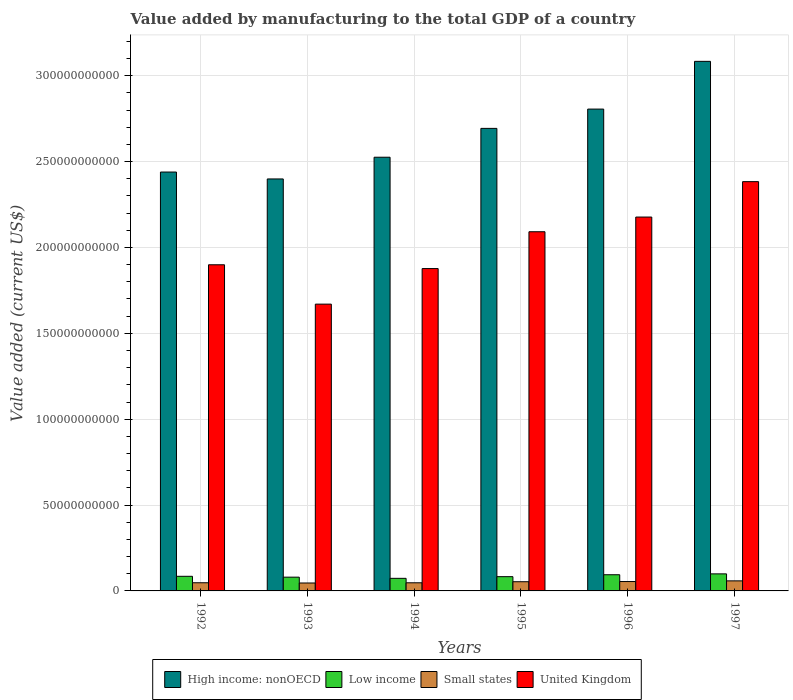How many groups of bars are there?
Provide a succinct answer. 6. Are the number of bars per tick equal to the number of legend labels?
Provide a short and direct response. Yes. Are the number of bars on each tick of the X-axis equal?
Provide a short and direct response. Yes. What is the value added by manufacturing to the total GDP in Low income in 1996?
Keep it short and to the point. 9.42e+09. Across all years, what is the maximum value added by manufacturing to the total GDP in Low income?
Give a very brief answer. 9.93e+09. Across all years, what is the minimum value added by manufacturing to the total GDP in High income: nonOECD?
Ensure brevity in your answer.  2.40e+11. What is the total value added by manufacturing to the total GDP in United Kingdom in the graph?
Ensure brevity in your answer.  1.21e+12. What is the difference between the value added by manufacturing to the total GDP in High income: nonOECD in 1994 and that in 1996?
Your answer should be compact. -2.80e+1. What is the difference between the value added by manufacturing to the total GDP in Small states in 1996 and the value added by manufacturing to the total GDP in High income: nonOECD in 1995?
Offer a terse response. -2.64e+11. What is the average value added by manufacturing to the total GDP in High income: nonOECD per year?
Keep it short and to the point. 2.66e+11. In the year 1995, what is the difference between the value added by manufacturing to the total GDP in Low income and value added by manufacturing to the total GDP in Small states?
Make the answer very short. 2.94e+09. What is the ratio of the value added by manufacturing to the total GDP in United Kingdom in 1993 to that in 1995?
Offer a very short reply. 0.8. What is the difference between the highest and the second highest value added by manufacturing to the total GDP in High income: nonOECD?
Your answer should be very brief. 2.78e+1. What is the difference between the highest and the lowest value added by manufacturing to the total GDP in High income: nonOECD?
Make the answer very short. 6.85e+1. Is it the case that in every year, the sum of the value added by manufacturing to the total GDP in High income: nonOECD and value added by manufacturing to the total GDP in Low income is greater than the sum of value added by manufacturing to the total GDP in United Kingdom and value added by manufacturing to the total GDP in Small states?
Ensure brevity in your answer.  Yes. What does the 2nd bar from the right in 1997 represents?
Your answer should be compact. Small states. Is it the case that in every year, the sum of the value added by manufacturing to the total GDP in Low income and value added by manufacturing to the total GDP in Small states is greater than the value added by manufacturing to the total GDP in United Kingdom?
Give a very brief answer. No. How many bars are there?
Your response must be concise. 24. Are all the bars in the graph horizontal?
Provide a short and direct response. No. How many years are there in the graph?
Offer a very short reply. 6. Does the graph contain any zero values?
Provide a succinct answer. No. Does the graph contain grids?
Your response must be concise. Yes. Where does the legend appear in the graph?
Offer a terse response. Bottom center. What is the title of the graph?
Offer a terse response. Value added by manufacturing to the total GDP of a country. What is the label or title of the Y-axis?
Keep it short and to the point. Value added (current US$). What is the Value added (current US$) of High income: nonOECD in 1992?
Provide a succinct answer. 2.44e+11. What is the Value added (current US$) in Low income in 1992?
Offer a very short reply. 8.51e+09. What is the Value added (current US$) in Small states in 1992?
Your answer should be very brief. 4.76e+09. What is the Value added (current US$) of United Kingdom in 1992?
Your answer should be compact. 1.90e+11. What is the Value added (current US$) in High income: nonOECD in 1993?
Provide a short and direct response. 2.40e+11. What is the Value added (current US$) in Low income in 1993?
Your answer should be compact. 8.01e+09. What is the Value added (current US$) of Small states in 1993?
Provide a short and direct response. 4.62e+09. What is the Value added (current US$) of United Kingdom in 1993?
Ensure brevity in your answer.  1.67e+11. What is the Value added (current US$) in High income: nonOECD in 1994?
Offer a terse response. 2.53e+11. What is the Value added (current US$) of Low income in 1994?
Provide a succinct answer. 7.33e+09. What is the Value added (current US$) of Small states in 1994?
Offer a very short reply. 4.74e+09. What is the Value added (current US$) in United Kingdom in 1994?
Offer a terse response. 1.88e+11. What is the Value added (current US$) of High income: nonOECD in 1995?
Your answer should be compact. 2.69e+11. What is the Value added (current US$) in Low income in 1995?
Offer a very short reply. 8.30e+09. What is the Value added (current US$) in Small states in 1995?
Make the answer very short. 5.35e+09. What is the Value added (current US$) in United Kingdom in 1995?
Make the answer very short. 2.09e+11. What is the Value added (current US$) of High income: nonOECD in 1996?
Give a very brief answer. 2.81e+11. What is the Value added (current US$) in Low income in 1996?
Provide a succinct answer. 9.42e+09. What is the Value added (current US$) of Small states in 1996?
Your answer should be very brief. 5.46e+09. What is the Value added (current US$) in United Kingdom in 1996?
Provide a short and direct response. 2.18e+11. What is the Value added (current US$) of High income: nonOECD in 1997?
Give a very brief answer. 3.08e+11. What is the Value added (current US$) in Low income in 1997?
Offer a terse response. 9.93e+09. What is the Value added (current US$) of Small states in 1997?
Your response must be concise. 5.85e+09. What is the Value added (current US$) in United Kingdom in 1997?
Keep it short and to the point. 2.38e+11. Across all years, what is the maximum Value added (current US$) in High income: nonOECD?
Provide a short and direct response. 3.08e+11. Across all years, what is the maximum Value added (current US$) in Low income?
Provide a succinct answer. 9.93e+09. Across all years, what is the maximum Value added (current US$) in Small states?
Your answer should be very brief. 5.85e+09. Across all years, what is the maximum Value added (current US$) of United Kingdom?
Ensure brevity in your answer.  2.38e+11. Across all years, what is the minimum Value added (current US$) in High income: nonOECD?
Offer a terse response. 2.40e+11. Across all years, what is the minimum Value added (current US$) of Low income?
Keep it short and to the point. 7.33e+09. Across all years, what is the minimum Value added (current US$) in Small states?
Provide a short and direct response. 4.62e+09. Across all years, what is the minimum Value added (current US$) of United Kingdom?
Give a very brief answer. 1.67e+11. What is the total Value added (current US$) in High income: nonOECD in the graph?
Your response must be concise. 1.59e+12. What is the total Value added (current US$) of Low income in the graph?
Your answer should be compact. 5.15e+1. What is the total Value added (current US$) of Small states in the graph?
Give a very brief answer. 3.08e+1. What is the total Value added (current US$) in United Kingdom in the graph?
Keep it short and to the point. 1.21e+12. What is the difference between the Value added (current US$) of High income: nonOECD in 1992 and that in 1993?
Make the answer very short. 4.03e+09. What is the difference between the Value added (current US$) in Low income in 1992 and that in 1993?
Make the answer very short. 5.07e+08. What is the difference between the Value added (current US$) of Small states in 1992 and that in 1993?
Offer a very short reply. 1.36e+08. What is the difference between the Value added (current US$) in United Kingdom in 1992 and that in 1993?
Your answer should be compact. 2.29e+1. What is the difference between the Value added (current US$) in High income: nonOECD in 1992 and that in 1994?
Give a very brief answer. -8.62e+09. What is the difference between the Value added (current US$) in Low income in 1992 and that in 1994?
Make the answer very short. 1.18e+09. What is the difference between the Value added (current US$) in Small states in 1992 and that in 1994?
Ensure brevity in your answer.  2.15e+07. What is the difference between the Value added (current US$) of United Kingdom in 1992 and that in 1994?
Give a very brief answer. 2.21e+09. What is the difference between the Value added (current US$) in High income: nonOECD in 1992 and that in 1995?
Your response must be concise. -2.54e+1. What is the difference between the Value added (current US$) in Low income in 1992 and that in 1995?
Keep it short and to the point. 2.16e+08. What is the difference between the Value added (current US$) in Small states in 1992 and that in 1995?
Provide a short and direct response. -5.97e+08. What is the difference between the Value added (current US$) of United Kingdom in 1992 and that in 1995?
Your answer should be very brief. -1.92e+1. What is the difference between the Value added (current US$) in High income: nonOECD in 1992 and that in 1996?
Your answer should be compact. -3.67e+1. What is the difference between the Value added (current US$) in Low income in 1992 and that in 1996?
Your response must be concise. -9.07e+08. What is the difference between the Value added (current US$) of Small states in 1992 and that in 1996?
Provide a short and direct response. -7.06e+08. What is the difference between the Value added (current US$) of United Kingdom in 1992 and that in 1996?
Your response must be concise. -2.78e+1. What is the difference between the Value added (current US$) in High income: nonOECD in 1992 and that in 1997?
Your response must be concise. -6.44e+1. What is the difference between the Value added (current US$) in Low income in 1992 and that in 1997?
Provide a short and direct response. -1.41e+09. What is the difference between the Value added (current US$) in Small states in 1992 and that in 1997?
Offer a very short reply. -1.10e+09. What is the difference between the Value added (current US$) of United Kingdom in 1992 and that in 1997?
Make the answer very short. -4.84e+1. What is the difference between the Value added (current US$) in High income: nonOECD in 1993 and that in 1994?
Your answer should be very brief. -1.26e+1. What is the difference between the Value added (current US$) of Low income in 1993 and that in 1994?
Your answer should be very brief. 6.75e+08. What is the difference between the Value added (current US$) of Small states in 1993 and that in 1994?
Your answer should be compact. -1.15e+08. What is the difference between the Value added (current US$) in United Kingdom in 1993 and that in 1994?
Your answer should be very brief. -2.07e+1. What is the difference between the Value added (current US$) of High income: nonOECD in 1993 and that in 1995?
Ensure brevity in your answer.  -2.94e+1. What is the difference between the Value added (current US$) in Low income in 1993 and that in 1995?
Provide a short and direct response. -2.91e+08. What is the difference between the Value added (current US$) of Small states in 1993 and that in 1995?
Provide a short and direct response. -7.33e+08. What is the difference between the Value added (current US$) in United Kingdom in 1993 and that in 1995?
Your answer should be very brief. -4.21e+1. What is the difference between the Value added (current US$) in High income: nonOECD in 1993 and that in 1996?
Your answer should be very brief. -4.07e+1. What is the difference between the Value added (current US$) of Low income in 1993 and that in 1996?
Give a very brief answer. -1.41e+09. What is the difference between the Value added (current US$) of Small states in 1993 and that in 1996?
Offer a very short reply. -8.42e+08. What is the difference between the Value added (current US$) in United Kingdom in 1993 and that in 1996?
Offer a very short reply. -5.07e+1. What is the difference between the Value added (current US$) of High income: nonOECD in 1993 and that in 1997?
Offer a terse response. -6.85e+1. What is the difference between the Value added (current US$) in Low income in 1993 and that in 1997?
Ensure brevity in your answer.  -1.92e+09. What is the difference between the Value added (current US$) in Small states in 1993 and that in 1997?
Provide a short and direct response. -1.23e+09. What is the difference between the Value added (current US$) in United Kingdom in 1993 and that in 1997?
Provide a short and direct response. -7.13e+1. What is the difference between the Value added (current US$) in High income: nonOECD in 1994 and that in 1995?
Your answer should be compact. -1.68e+1. What is the difference between the Value added (current US$) in Low income in 1994 and that in 1995?
Offer a very short reply. -9.66e+08. What is the difference between the Value added (current US$) of Small states in 1994 and that in 1995?
Your response must be concise. -6.18e+08. What is the difference between the Value added (current US$) of United Kingdom in 1994 and that in 1995?
Provide a succinct answer. -2.14e+1. What is the difference between the Value added (current US$) of High income: nonOECD in 1994 and that in 1996?
Provide a succinct answer. -2.80e+1. What is the difference between the Value added (current US$) in Low income in 1994 and that in 1996?
Provide a short and direct response. -2.09e+09. What is the difference between the Value added (current US$) of Small states in 1994 and that in 1996?
Offer a terse response. -7.27e+08. What is the difference between the Value added (current US$) in United Kingdom in 1994 and that in 1996?
Give a very brief answer. -3.00e+1. What is the difference between the Value added (current US$) in High income: nonOECD in 1994 and that in 1997?
Your response must be concise. -5.58e+1. What is the difference between the Value added (current US$) in Low income in 1994 and that in 1997?
Make the answer very short. -2.59e+09. What is the difference between the Value added (current US$) of Small states in 1994 and that in 1997?
Keep it short and to the point. -1.12e+09. What is the difference between the Value added (current US$) in United Kingdom in 1994 and that in 1997?
Your answer should be compact. -5.06e+1. What is the difference between the Value added (current US$) in High income: nonOECD in 1995 and that in 1996?
Your answer should be compact. -1.12e+1. What is the difference between the Value added (current US$) of Low income in 1995 and that in 1996?
Offer a very short reply. -1.12e+09. What is the difference between the Value added (current US$) in Small states in 1995 and that in 1996?
Make the answer very short. -1.09e+08. What is the difference between the Value added (current US$) in United Kingdom in 1995 and that in 1996?
Keep it short and to the point. -8.56e+09. What is the difference between the Value added (current US$) of High income: nonOECD in 1995 and that in 1997?
Your answer should be compact. -3.90e+1. What is the difference between the Value added (current US$) of Low income in 1995 and that in 1997?
Your answer should be compact. -1.63e+09. What is the difference between the Value added (current US$) in Small states in 1995 and that in 1997?
Offer a terse response. -5.00e+08. What is the difference between the Value added (current US$) of United Kingdom in 1995 and that in 1997?
Give a very brief answer. -2.92e+1. What is the difference between the Value added (current US$) in High income: nonOECD in 1996 and that in 1997?
Offer a very short reply. -2.78e+1. What is the difference between the Value added (current US$) in Low income in 1996 and that in 1997?
Give a very brief answer. -5.06e+08. What is the difference between the Value added (current US$) in Small states in 1996 and that in 1997?
Keep it short and to the point. -3.91e+08. What is the difference between the Value added (current US$) of United Kingdom in 1996 and that in 1997?
Provide a succinct answer. -2.06e+1. What is the difference between the Value added (current US$) in High income: nonOECD in 1992 and the Value added (current US$) in Low income in 1993?
Offer a terse response. 2.36e+11. What is the difference between the Value added (current US$) of High income: nonOECD in 1992 and the Value added (current US$) of Small states in 1993?
Your answer should be very brief. 2.39e+11. What is the difference between the Value added (current US$) in High income: nonOECD in 1992 and the Value added (current US$) in United Kingdom in 1993?
Offer a terse response. 7.69e+1. What is the difference between the Value added (current US$) of Low income in 1992 and the Value added (current US$) of Small states in 1993?
Make the answer very short. 3.89e+09. What is the difference between the Value added (current US$) of Low income in 1992 and the Value added (current US$) of United Kingdom in 1993?
Give a very brief answer. -1.58e+11. What is the difference between the Value added (current US$) of Small states in 1992 and the Value added (current US$) of United Kingdom in 1993?
Provide a succinct answer. -1.62e+11. What is the difference between the Value added (current US$) of High income: nonOECD in 1992 and the Value added (current US$) of Low income in 1994?
Ensure brevity in your answer.  2.37e+11. What is the difference between the Value added (current US$) in High income: nonOECD in 1992 and the Value added (current US$) in Small states in 1994?
Your response must be concise. 2.39e+11. What is the difference between the Value added (current US$) of High income: nonOECD in 1992 and the Value added (current US$) of United Kingdom in 1994?
Keep it short and to the point. 5.62e+1. What is the difference between the Value added (current US$) of Low income in 1992 and the Value added (current US$) of Small states in 1994?
Offer a terse response. 3.78e+09. What is the difference between the Value added (current US$) in Low income in 1992 and the Value added (current US$) in United Kingdom in 1994?
Your answer should be very brief. -1.79e+11. What is the difference between the Value added (current US$) of Small states in 1992 and the Value added (current US$) of United Kingdom in 1994?
Offer a very short reply. -1.83e+11. What is the difference between the Value added (current US$) in High income: nonOECD in 1992 and the Value added (current US$) in Low income in 1995?
Your response must be concise. 2.36e+11. What is the difference between the Value added (current US$) of High income: nonOECD in 1992 and the Value added (current US$) of Small states in 1995?
Offer a very short reply. 2.39e+11. What is the difference between the Value added (current US$) in High income: nonOECD in 1992 and the Value added (current US$) in United Kingdom in 1995?
Your response must be concise. 3.48e+1. What is the difference between the Value added (current US$) in Low income in 1992 and the Value added (current US$) in Small states in 1995?
Your answer should be very brief. 3.16e+09. What is the difference between the Value added (current US$) of Low income in 1992 and the Value added (current US$) of United Kingdom in 1995?
Make the answer very short. -2.01e+11. What is the difference between the Value added (current US$) of Small states in 1992 and the Value added (current US$) of United Kingdom in 1995?
Provide a succinct answer. -2.04e+11. What is the difference between the Value added (current US$) in High income: nonOECD in 1992 and the Value added (current US$) in Low income in 1996?
Give a very brief answer. 2.34e+11. What is the difference between the Value added (current US$) in High income: nonOECD in 1992 and the Value added (current US$) in Small states in 1996?
Your answer should be very brief. 2.38e+11. What is the difference between the Value added (current US$) of High income: nonOECD in 1992 and the Value added (current US$) of United Kingdom in 1996?
Your response must be concise. 2.62e+1. What is the difference between the Value added (current US$) in Low income in 1992 and the Value added (current US$) in Small states in 1996?
Your response must be concise. 3.05e+09. What is the difference between the Value added (current US$) in Low income in 1992 and the Value added (current US$) in United Kingdom in 1996?
Offer a terse response. -2.09e+11. What is the difference between the Value added (current US$) in Small states in 1992 and the Value added (current US$) in United Kingdom in 1996?
Provide a short and direct response. -2.13e+11. What is the difference between the Value added (current US$) in High income: nonOECD in 1992 and the Value added (current US$) in Low income in 1997?
Your answer should be compact. 2.34e+11. What is the difference between the Value added (current US$) of High income: nonOECD in 1992 and the Value added (current US$) of Small states in 1997?
Keep it short and to the point. 2.38e+11. What is the difference between the Value added (current US$) of High income: nonOECD in 1992 and the Value added (current US$) of United Kingdom in 1997?
Offer a very short reply. 5.59e+09. What is the difference between the Value added (current US$) in Low income in 1992 and the Value added (current US$) in Small states in 1997?
Provide a succinct answer. 2.66e+09. What is the difference between the Value added (current US$) in Low income in 1992 and the Value added (current US$) in United Kingdom in 1997?
Your answer should be compact. -2.30e+11. What is the difference between the Value added (current US$) in Small states in 1992 and the Value added (current US$) in United Kingdom in 1997?
Offer a terse response. -2.34e+11. What is the difference between the Value added (current US$) in High income: nonOECD in 1993 and the Value added (current US$) in Low income in 1994?
Provide a succinct answer. 2.33e+11. What is the difference between the Value added (current US$) of High income: nonOECD in 1993 and the Value added (current US$) of Small states in 1994?
Provide a succinct answer. 2.35e+11. What is the difference between the Value added (current US$) of High income: nonOECD in 1993 and the Value added (current US$) of United Kingdom in 1994?
Offer a terse response. 5.22e+1. What is the difference between the Value added (current US$) of Low income in 1993 and the Value added (current US$) of Small states in 1994?
Keep it short and to the point. 3.27e+09. What is the difference between the Value added (current US$) of Low income in 1993 and the Value added (current US$) of United Kingdom in 1994?
Provide a short and direct response. -1.80e+11. What is the difference between the Value added (current US$) of Small states in 1993 and the Value added (current US$) of United Kingdom in 1994?
Provide a succinct answer. -1.83e+11. What is the difference between the Value added (current US$) of High income: nonOECD in 1993 and the Value added (current US$) of Low income in 1995?
Offer a very short reply. 2.32e+11. What is the difference between the Value added (current US$) in High income: nonOECD in 1993 and the Value added (current US$) in Small states in 1995?
Your answer should be very brief. 2.35e+11. What is the difference between the Value added (current US$) in High income: nonOECD in 1993 and the Value added (current US$) in United Kingdom in 1995?
Your answer should be compact. 3.07e+1. What is the difference between the Value added (current US$) in Low income in 1993 and the Value added (current US$) in Small states in 1995?
Make the answer very short. 2.65e+09. What is the difference between the Value added (current US$) in Low income in 1993 and the Value added (current US$) in United Kingdom in 1995?
Your answer should be compact. -2.01e+11. What is the difference between the Value added (current US$) of Small states in 1993 and the Value added (current US$) of United Kingdom in 1995?
Provide a short and direct response. -2.05e+11. What is the difference between the Value added (current US$) of High income: nonOECD in 1993 and the Value added (current US$) of Low income in 1996?
Ensure brevity in your answer.  2.30e+11. What is the difference between the Value added (current US$) of High income: nonOECD in 1993 and the Value added (current US$) of Small states in 1996?
Your response must be concise. 2.34e+11. What is the difference between the Value added (current US$) of High income: nonOECD in 1993 and the Value added (current US$) of United Kingdom in 1996?
Make the answer very short. 2.22e+1. What is the difference between the Value added (current US$) of Low income in 1993 and the Value added (current US$) of Small states in 1996?
Your answer should be compact. 2.54e+09. What is the difference between the Value added (current US$) in Low income in 1993 and the Value added (current US$) in United Kingdom in 1996?
Your answer should be very brief. -2.10e+11. What is the difference between the Value added (current US$) in Small states in 1993 and the Value added (current US$) in United Kingdom in 1996?
Ensure brevity in your answer.  -2.13e+11. What is the difference between the Value added (current US$) of High income: nonOECD in 1993 and the Value added (current US$) of Low income in 1997?
Your answer should be compact. 2.30e+11. What is the difference between the Value added (current US$) of High income: nonOECD in 1993 and the Value added (current US$) of Small states in 1997?
Your answer should be compact. 2.34e+11. What is the difference between the Value added (current US$) of High income: nonOECD in 1993 and the Value added (current US$) of United Kingdom in 1997?
Provide a succinct answer. 1.57e+09. What is the difference between the Value added (current US$) in Low income in 1993 and the Value added (current US$) in Small states in 1997?
Your answer should be compact. 2.15e+09. What is the difference between the Value added (current US$) in Low income in 1993 and the Value added (current US$) in United Kingdom in 1997?
Give a very brief answer. -2.30e+11. What is the difference between the Value added (current US$) of Small states in 1993 and the Value added (current US$) of United Kingdom in 1997?
Your answer should be compact. -2.34e+11. What is the difference between the Value added (current US$) in High income: nonOECD in 1994 and the Value added (current US$) in Low income in 1995?
Make the answer very short. 2.44e+11. What is the difference between the Value added (current US$) in High income: nonOECD in 1994 and the Value added (current US$) in Small states in 1995?
Offer a very short reply. 2.47e+11. What is the difference between the Value added (current US$) of High income: nonOECD in 1994 and the Value added (current US$) of United Kingdom in 1995?
Offer a terse response. 4.34e+1. What is the difference between the Value added (current US$) of Low income in 1994 and the Value added (current US$) of Small states in 1995?
Offer a terse response. 1.98e+09. What is the difference between the Value added (current US$) in Low income in 1994 and the Value added (current US$) in United Kingdom in 1995?
Give a very brief answer. -2.02e+11. What is the difference between the Value added (current US$) of Small states in 1994 and the Value added (current US$) of United Kingdom in 1995?
Make the answer very short. -2.04e+11. What is the difference between the Value added (current US$) in High income: nonOECD in 1994 and the Value added (current US$) in Low income in 1996?
Offer a terse response. 2.43e+11. What is the difference between the Value added (current US$) of High income: nonOECD in 1994 and the Value added (current US$) of Small states in 1996?
Make the answer very short. 2.47e+11. What is the difference between the Value added (current US$) of High income: nonOECD in 1994 and the Value added (current US$) of United Kingdom in 1996?
Offer a very short reply. 3.48e+1. What is the difference between the Value added (current US$) of Low income in 1994 and the Value added (current US$) of Small states in 1996?
Offer a terse response. 1.87e+09. What is the difference between the Value added (current US$) of Low income in 1994 and the Value added (current US$) of United Kingdom in 1996?
Offer a very short reply. -2.10e+11. What is the difference between the Value added (current US$) in Small states in 1994 and the Value added (current US$) in United Kingdom in 1996?
Ensure brevity in your answer.  -2.13e+11. What is the difference between the Value added (current US$) of High income: nonOECD in 1994 and the Value added (current US$) of Low income in 1997?
Offer a very short reply. 2.43e+11. What is the difference between the Value added (current US$) of High income: nonOECD in 1994 and the Value added (current US$) of Small states in 1997?
Give a very brief answer. 2.47e+11. What is the difference between the Value added (current US$) in High income: nonOECD in 1994 and the Value added (current US$) in United Kingdom in 1997?
Your answer should be compact. 1.42e+1. What is the difference between the Value added (current US$) in Low income in 1994 and the Value added (current US$) in Small states in 1997?
Your response must be concise. 1.48e+09. What is the difference between the Value added (current US$) of Low income in 1994 and the Value added (current US$) of United Kingdom in 1997?
Provide a short and direct response. -2.31e+11. What is the difference between the Value added (current US$) of Small states in 1994 and the Value added (current US$) of United Kingdom in 1997?
Keep it short and to the point. -2.34e+11. What is the difference between the Value added (current US$) of High income: nonOECD in 1995 and the Value added (current US$) of Low income in 1996?
Your response must be concise. 2.60e+11. What is the difference between the Value added (current US$) of High income: nonOECD in 1995 and the Value added (current US$) of Small states in 1996?
Offer a terse response. 2.64e+11. What is the difference between the Value added (current US$) in High income: nonOECD in 1995 and the Value added (current US$) in United Kingdom in 1996?
Your response must be concise. 5.16e+1. What is the difference between the Value added (current US$) of Low income in 1995 and the Value added (current US$) of Small states in 1996?
Make the answer very short. 2.84e+09. What is the difference between the Value added (current US$) in Low income in 1995 and the Value added (current US$) in United Kingdom in 1996?
Provide a succinct answer. -2.09e+11. What is the difference between the Value added (current US$) in Small states in 1995 and the Value added (current US$) in United Kingdom in 1996?
Offer a very short reply. -2.12e+11. What is the difference between the Value added (current US$) of High income: nonOECD in 1995 and the Value added (current US$) of Low income in 1997?
Your answer should be compact. 2.59e+11. What is the difference between the Value added (current US$) in High income: nonOECD in 1995 and the Value added (current US$) in Small states in 1997?
Offer a terse response. 2.63e+11. What is the difference between the Value added (current US$) of High income: nonOECD in 1995 and the Value added (current US$) of United Kingdom in 1997?
Keep it short and to the point. 3.10e+1. What is the difference between the Value added (current US$) in Low income in 1995 and the Value added (current US$) in Small states in 1997?
Your answer should be compact. 2.44e+09. What is the difference between the Value added (current US$) of Low income in 1995 and the Value added (current US$) of United Kingdom in 1997?
Make the answer very short. -2.30e+11. What is the difference between the Value added (current US$) of Small states in 1995 and the Value added (current US$) of United Kingdom in 1997?
Your response must be concise. -2.33e+11. What is the difference between the Value added (current US$) of High income: nonOECD in 1996 and the Value added (current US$) of Low income in 1997?
Give a very brief answer. 2.71e+11. What is the difference between the Value added (current US$) of High income: nonOECD in 1996 and the Value added (current US$) of Small states in 1997?
Provide a succinct answer. 2.75e+11. What is the difference between the Value added (current US$) of High income: nonOECD in 1996 and the Value added (current US$) of United Kingdom in 1997?
Provide a succinct answer. 4.22e+1. What is the difference between the Value added (current US$) of Low income in 1996 and the Value added (current US$) of Small states in 1997?
Give a very brief answer. 3.57e+09. What is the difference between the Value added (current US$) of Low income in 1996 and the Value added (current US$) of United Kingdom in 1997?
Give a very brief answer. -2.29e+11. What is the difference between the Value added (current US$) of Small states in 1996 and the Value added (current US$) of United Kingdom in 1997?
Ensure brevity in your answer.  -2.33e+11. What is the average Value added (current US$) in High income: nonOECD per year?
Keep it short and to the point. 2.66e+11. What is the average Value added (current US$) of Low income per year?
Make the answer very short. 8.58e+09. What is the average Value added (current US$) of Small states per year?
Make the answer very short. 5.13e+09. What is the average Value added (current US$) in United Kingdom per year?
Provide a short and direct response. 2.02e+11. In the year 1992, what is the difference between the Value added (current US$) in High income: nonOECD and Value added (current US$) in Low income?
Your response must be concise. 2.35e+11. In the year 1992, what is the difference between the Value added (current US$) of High income: nonOECD and Value added (current US$) of Small states?
Your answer should be compact. 2.39e+11. In the year 1992, what is the difference between the Value added (current US$) of High income: nonOECD and Value added (current US$) of United Kingdom?
Give a very brief answer. 5.40e+1. In the year 1992, what is the difference between the Value added (current US$) of Low income and Value added (current US$) of Small states?
Make the answer very short. 3.76e+09. In the year 1992, what is the difference between the Value added (current US$) of Low income and Value added (current US$) of United Kingdom?
Make the answer very short. -1.81e+11. In the year 1992, what is the difference between the Value added (current US$) of Small states and Value added (current US$) of United Kingdom?
Keep it short and to the point. -1.85e+11. In the year 1993, what is the difference between the Value added (current US$) of High income: nonOECD and Value added (current US$) of Low income?
Make the answer very short. 2.32e+11. In the year 1993, what is the difference between the Value added (current US$) in High income: nonOECD and Value added (current US$) in Small states?
Your answer should be very brief. 2.35e+11. In the year 1993, what is the difference between the Value added (current US$) in High income: nonOECD and Value added (current US$) in United Kingdom?
Ensure brevity in your answer.  7.29e+1. In the year 1993, what is the difference between the Value added (current US$) in Low income and Value added (current US$) in Small states?
Offer a terse response. 3.39e+09. In the year 1993, what is the difference between the Value added (current US$) of Low income and Value added (current US$) of United Kingdom?
Provide a succinct answer. -1.59e+11. In the year 1993, what is the difference between the Value added (current US$) of Small states and Value added (current US$) of United Kingdom?
Provide a short and direct response. -1.62e+11. In the year 1994, what is the difference between the Value added (current US$) of High income: nonOECD and Value added (current US$) of Low income?
Your answer should be compact. 2.45e+11. In the year 1994, what is the difference between the Value added (current US$) of High income: nonOECD and Value added (current US$) of Small states?
Provide a succinct answer. 2.48e+11. In the year 1994, what is the difference between the Value added (current US$) of High income: nonOECD and Value added (current US$) of United Kingdom?
Offer a terse response. 6.48e+1. In the year 1994, what is the difference between the Value added (current US$) of Low income and Value added (current US$) of Small states?
Keep it short and to the point. 2.60e+09. In the year 1994, what is the difference between the Value added (current US$) of Low income and Value added (current US$) of United Kingdom?
Provide a succinct answer. -1.80e+11. In the year 1994, what is the difference between the Value added (current US$) of Small states and Value added (current US$) of United Kingdom?
Your answer should be compact. -1.83e+11. In the year 1995, what is the difference between the Value added (current US$) of High income: nonOECD and Value added (current US$) of Low income?
Ensure brevity in your answer.  2.61e+11. In the year 1995, what is the difference between the Value added (current US$) of High income: nonOECD and Value added (current US$) of Small states?
Keep it short and to the point. 2.64e+11. In the year 1995, what is the difference between the Value added (current US$) in High income: nonOECD and Value added (current US$) in United Kingdom?
Your answer should be compact. 6.02e+1. In the year 1995, what is the difference between the Value added (current US$) in Low income and Value added (current US$) in Small states?
Keep it short and to the point. 2.94e+09. In the year 1995, what is the difference between the Value added (current US$) in Low income and Value added (current US$) in United Kingdom?
Ensure brevity in your answer.  -2.01e+11. In the year 1995, what is the difference between the Value added (current US$) in Small states and Value added (current US$) in United Kingdom?
Offer a very short reply. -2.04e+11. In the year 1996, what is the difference between the Value added (current US$) of High income: nonOECD and Value added (current US$) of Low income?
Your response must be concise. 2.71e+11. In the year 1996, what is the difference between the Value added (current US$) of High income: nonOECD and Value added (current US$) of Small states?
Ensure brevity in your answer.  2.75e+11. In the year 1996, what is the difference between the Value added (current US$) of High income: nonOECD and Value added (current US$) of United Kingdom?
Your response must be concise. 6.29e+1. In the year 1996, what is the difference between the Value added (current US$) of Low income and Value added (current US$) of Small states?
Provide a succinct answer. 3.96e+09. In the year 1996, what is the difference between the Value added (current US$) of Low income and Value added (current US$) of United Kingdom?
Your answer should be very brief. -2.08e+11. In the year 1996, what is the difference between the Value added (current US$) in Small states and Value added (current US$) in United Kingdom?
Your answer should be compact. -2.12e+11. In the year 1997, what is the difference between the Value added (current US$) of High income: nonOECD and Value added (current US$) of Low income?
Offer a very short reply. 2.98e+11. In the year 1997, what is the difference between the Value added (current US$) of High income: nonOECD and Value added (current US$) of Small states?
Your answer should be very brief. 3.02e+11. In the year 1997, what is the difference between the Value added (current US$) in High income: nonOECD and Value added (current US$) in United Kingdom?
Your response must be concise. 7.00e+1. In the year 1997, what is the difference between the Value added (current US$) of Low income and Value added (current US$) of Small states?
Provide a succinct answer. 4.07e+09. In the year 1997, what is the difference between the Value added (current US$) in Low income and Value added (current US$) in United Kingdom?
Provide a succinct answer. -2.28e+11. In the year 1997, what is the difference between the Value added (current US$) of Small states and Value added (current US$) of United Kingdom?
Your response must be concise. -2.32e+11. What is the ratio of the Value added (current US$) of High income: nonOECD in 1992 to that in 1993?
Offer a very short reply. 1.02. What is the ratio of the Value added (current US$) of Low income in 1992 to that in 1993?
Provide a succinct answer. 1.06. What is the ratio of the Value added (current US$) in Small states in 1992 to that in 1993?
Make the answer very short. 1.03. What is the ratio of the Value added (current US$) in United Kingdom in 1992 to that in 1993?
Offer a very short reply. 1.14. What is the ratio of the Value added (current US$) of High income: nonOECD in 1992 to that in 1994?
Offer a very short reply. 0.97. What is the ratio of the Value added (current US$) of Low income in 1992 to that in 1994?
Ensure brevity in your answer.  1.16. What is the ratio of the Value added (current US$) of Small states in 1992 to that in 1994?
Provide a short and direct response. 1. What is the ratio of the Value added (current US$) in United Kingdom in 1992 to that in 1994?
Make the answer very short. 1.01. What is the ratio of the Value added (current US$) of High income: nonOECD in 1992 to that in 1995?
Your answer should be compact. 0.91. What is the ratio of the Value added (current US$) of Low income in 1992 to that in 1995?
Give a very brief answer. 1.03. What is the ratio of the Value added (current US$) of Small states in 1992 to that in 1995?
Offer a terse response. 0.89. What is the ratio of the Value added (current US$) of United Kingdom in 1992 to that in 1995?
Give a very brief answer. 0.91. What is the ratio of the Value added (current US$) in High income: nonOECD in 1992 to that in 1996?
Provide a succinct answer. 0.87. What is the ratio of the Value added (current US$) of Low income in 1992 to that in 1996?
Provide a succinct answer. 0.9. What is the ratio of the Value added (current US$) in Small states in 1992 to that in 1996?
Your answer should be compact. 0.87. What is the ratio of the Value added (current US$) in United Kingdom in 1992 to that in 1996?
Offer a terse response. 0.87. What is the ratio of the Value added (current US$) in High income: nonOECD in 1992 to that in 1997?
Give a very brief answer. 0.79. What is the ratio of the Value added (current US$) of Low income in 1992 to that in 1997?
Ensure brevity in your answer.  0.86. What is the ratio of the Value added (current US$) in Small states in 1992 to that in 1997?
Your answer should be compact. 0.81. What is the ratio of the Value added (current US$) of United Kingdom in 1992 to that in 1997?
Ensure brevity in your answer.  0.8. What is the ratio of the Value added (current US$) of High income: nonOECD in 1993 to that in 1994?
Your answer should be compact. 0.95. What is the ratio of the Value added (current US$) in Low income in 1993 to that in 1994?
Give a very brief answer. 1.09. What is the ratio of the Value added (current US$) in Small states in 1993 to that in 1994?
Make the answer very short. 0.98. What is the ratio of the Value added (current US$) in United Kingdom in 1993 to that in 1994?
Make the answer very short. 0.89. What is the ratio of the Value added (current US$) of High income: nonOECD in 1993 to that in 1995?
Your answer should be very brief. 0.89. What is the ratio of the Value added (current US$) of Low income in 1993 to that in 1995?
Keep it short and to the point. 0.96. What is the ratio of the Value added (current US$) of Small states in 1993 to that in 1995?
Keep it short and to the point. 0.86. What is the ratio of the Value added (current US$) of United Kingdom in 1993 to that in 1995?
Your answer should be very brief. 0.8. What is the ratio of the Value added (current US$) in High income: nonOECD in 1993 to that in 1996?
Make the answer very short. 0.85. What is the ratio of the Value added (current US$) in Low income in 1993 to that in 1996?
Provide a succinct answer. 0.85. What is the ratio of the Value added (current US$) of Small states in 1993 to that in 1996?
Your answer should be very brief. 0.85. What is the ratio of the Value added (current US$) of United Kingdom in 1993 to that in 1996?
Your answer should be very brief. 0.77. What is the ratio of the Value added (current US$) in High income: nonOECD in 1993 to that in 1997?
Ensure brevity in your answer.  0.78. What is the ratio of the Value added (current US$) of Low income in 1993 to that in 1997?
Your response must be concise. 0.81. What is the ratio of the Value added (current US$) of Small states in 1993 to that in 1997?
Provide a short and direct response. 0.79. What is the ratio of the Value added (current US$) in United Kingdom in 1993 to that in 1997?
Make the answer very short. 0.7. What is the ratio of the Value added (current US$) in High income: nonOECD in 1994 to that in 1995?
Your answer should be very brief. 0.94. What is the ratio of the Value added (current US$) in Low income in 1994 to that in 1995?
Keep it short and to the point. 0.88. What is the ratio of the Value added (current US$) of Small states in 1994 to that in 1995?
Offer a terse response. 0.88. What is the ratio of the Value added (current US$) in United Kingdom in 1994 to that in 1995?
Keep it short and to the point. 0.9. What is the ratio of the Value added (current US$) in High income: nonOECD in 1994 to that in 1996?
Give a very brief answer. 0.9. What is the ratio of the Value added (current US$) in Low income in 1994 to that in 1996?
Provide a short and direct response. 0.78. What is the ratio of the Value added (current US$) in Small states in 1994 to that in 1996?
Your answer should be very brief. 0.87. What is the ratio of the Value added (current US$) in United Kingdom in 1994 to that in 1996?
Your response must be concise. 0.86. What is the ratio of the Value added (current US$) of High income: nonOECD in 1994 to that in 1997?
Provide a short and direct response. 0.82. What is the ratio of the Value added (current US$) in Low income in 1994 to that in 1997?
Ensure brevity in your answer.  0.74. What is the ratio of the Value added (current US$) in Small states in 1994 to that in 1997?
Offer a terse response. 0.81. What is the ratio of the Value added (current US$) in United Kingdom in 1994 to that in 1997?
Give a very brief answer. 0.79. What is the ratio of the Value added (current US$) in Low income in 1995 to that in 1996?
Give a very brief answer. 0.88. What is the ratio of the Value added (current US$) in United Kingdom in 1995 to that in 1996?
Your response must be concise. 0.96. What is the ratio of the Value added (current US$) of High income: nonOECD in 1995 to that in 1997?
Offer a very short reply. 0.87. What is the ratio of the Value added (current US$) of Low income in 1995 to that in 1997?
Make the answer very short. 0.84. What is the ratio of the Value added (current US$) of Small states in 1995 to that in 1997?
Offer a terse response. 0.91. What is the ratio of the Value added (current US$) in United Kingdom in 1995 to that in 1997?
Offer a terse response. 0.88. What is the ratio of the Value added (current US$) in High income: nonOECD in 1996 to that in 1997?
Your response must be concise. 0.91. What is the ratio of the Value added (current US$) of Low income in 1996 to that in 1997?
Offer a terse response. 0.95. What is the ratio of the Value added (current US$) of Small states in 1996 to that in 1997?
Offer a terse response. 0.93. What is the ratio of the Value added (current US$) of United Kingdom in 1996 to that in 1997?
Ensure brevity in your answer.  0.91. What is the difference between the highest and the second highest Value added (current US$) of High income: nonOECD?
Provide a succinct answer. 2.78e+1. What is the difference between the highest and the second highest Value added (current US$) of Low income?
Offer a terse response. 5.06e+08. What is the difference between the highest and the second highest Value added (current US$) of Small states?
Keep it short and to the point. 3.91e+08. What is the difference between the highest and the second highest Value added (current US$) of United Kingdom?
Your answer should be very brief. 2.06e+1. What is the difference between the highest and the lowest Value added (current US$) of High income: nonOECD?
Provide a succinct answer. 6.85e+1. What is the difference between the highest and the lowest Value added (current US$) of Low income?
Ensure brevity in your answer.  2.59e+09. What is the difference between the highest and the lowest Value added (current US$) of Small states?
Provide a succinct answer. 1.23e+09. What is the difference between the highest and the lowest Value added (current US$) in United Kingdom?
Offer a very short reply. 7.13e+1. 